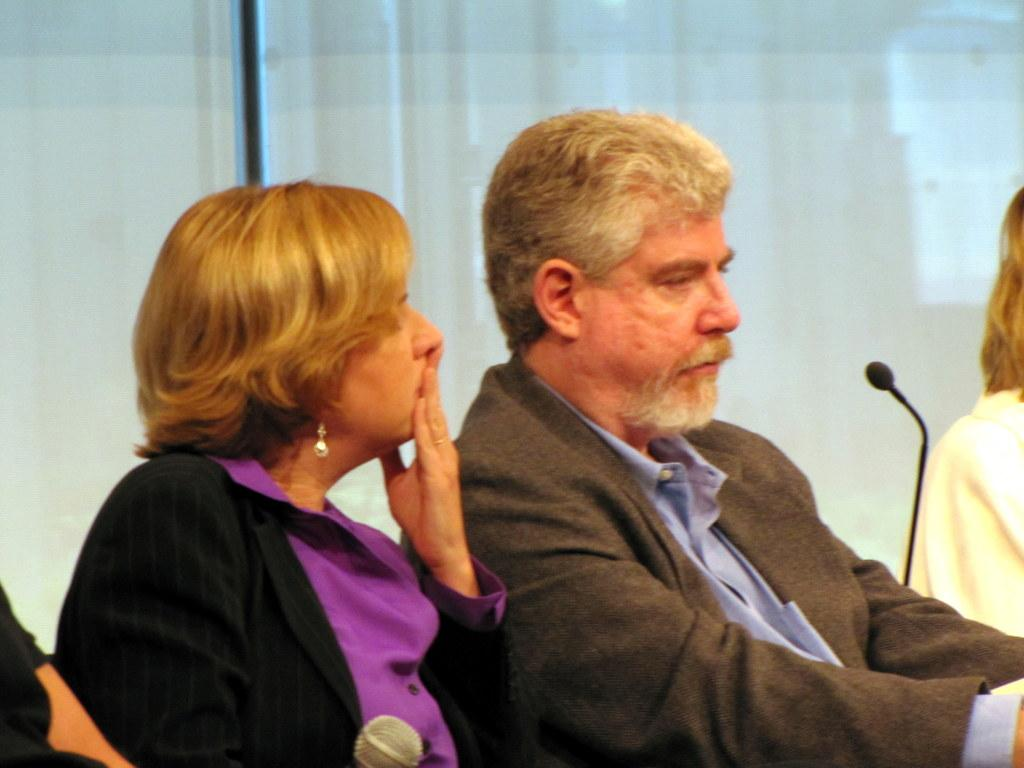Who or what can be seen in the image? There are people in the image. What objects are present that might be used for amplifying sound? There are mics in the image. What can be seen in the background of the image? There is a curtain and a rod in the background of the image. What type of treatment is being administered to the person in the image? There is no indication of any treatment being administered in the image. What body part is being treated in the image? There is no body part visible in the image, nor is there any indication of a treatment being administered. 